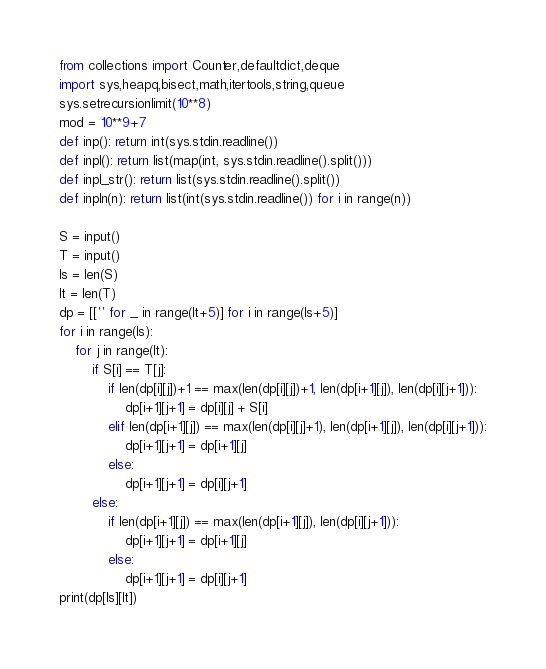Convert code to text. <code><loc_0><loc_0><loc_500><loc_500><_Python_>from collections import Counter,defaultdict,deque
import sys,heapq,bisect,math,itertools,string,queue
sys.setrecursionlimit(10**8)
mod = 10**9+7
def inp(): return int(sys.stdin.readline())
def inpl(): return list(map(int, sys.stdin.readline().split()))
def inpl_str(): return list(sys.stdin.readline().split())
def inpln(n): return list(int(sys.stdin.readline()) for i in range(n))

S = input()
T = input()
ls = len(S)
lt = len(T)
dp = [['' for _ in range(lt+5)] for i in range(ls+5)]
for i in range(ls):
    for j in range(lt):
        if S[i] == T[j]:
            if len(dp[i][j])+1 == max(len(dp[i][j])+1, len(dp[i+1][j]), len(dp[i][j+1])):
                dp[i+1][j+1] = dp[i][j] + S[i]
            elif len(dp[i+1][j]) == max(len(dp[i][j]+1), len(dp[i+1][j]), len(dp[i][j+1])):
                dp[i+1][j+1] = dp[i+1][j]
            else:
                dp[i+1][j+1] = dp[i][j+1]
        else:
            if len(dp[i+1][j]) == max(len(dp[i+1][j]), len(dp[i][j+1])):
                dp[i+1][j+1] = dp[i+1][j]
            else:
                dp[i+1][j+1] = dp[i][j+1]
print(dp[ls][lt])</code> 